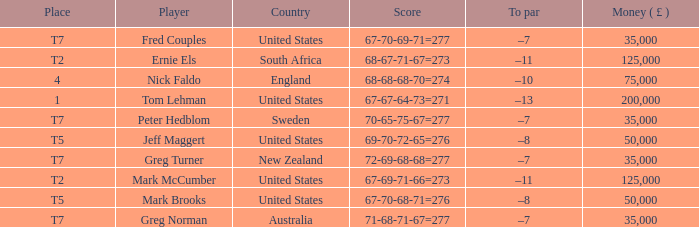What is To par, when Player is "Greg Turner"? –7. 